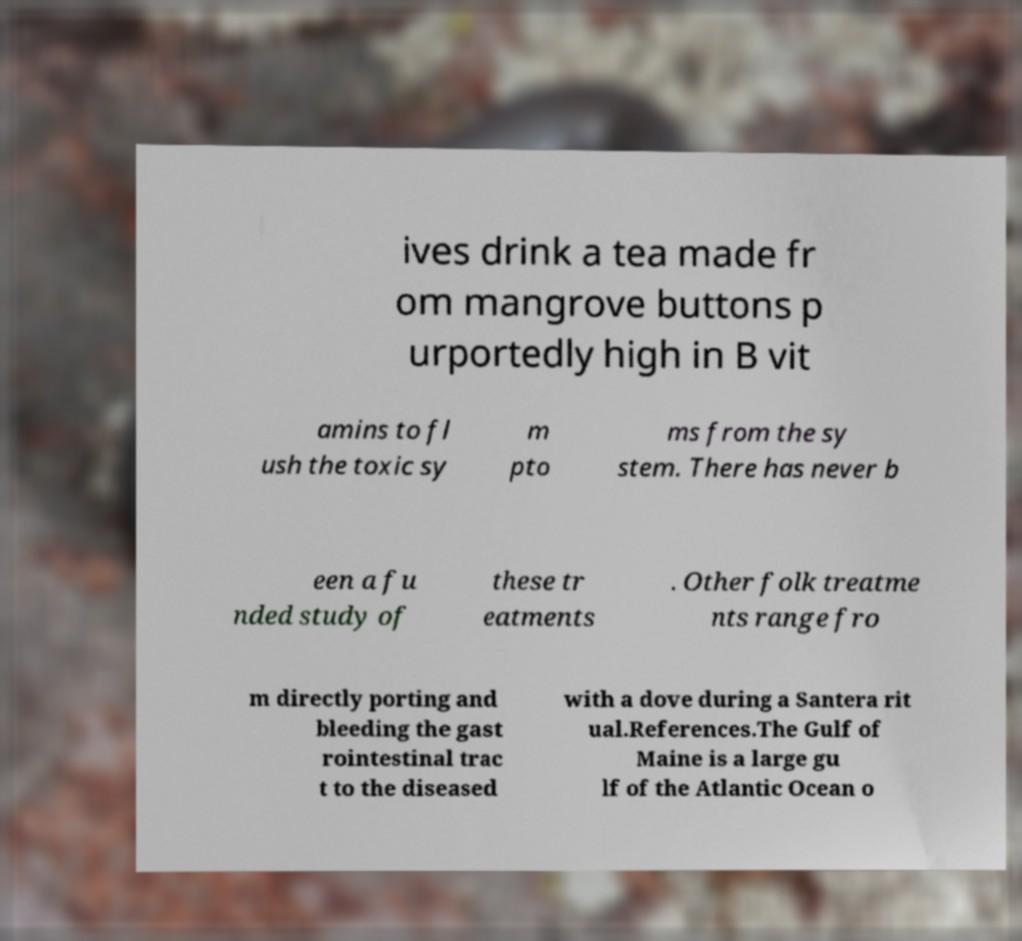Can you read and provide the text displayed in the image?This photo seems to have some interesting text. Can you extract and type it out for me? ives drink a tea made fr om mangrove buttons p urportedly high in B vit amins to fl ush the toxic sy m pto ms from the sy stem. There has never b een a fu nded study of these tr eatments . Other folk treatme nts range fro m directly porting and bleeding the gast rointestinal trac t to the diseased with a dove during a Santera rit ual.References.The Gulf of Maine is a large gu lf of the Atlantic Ocean o 